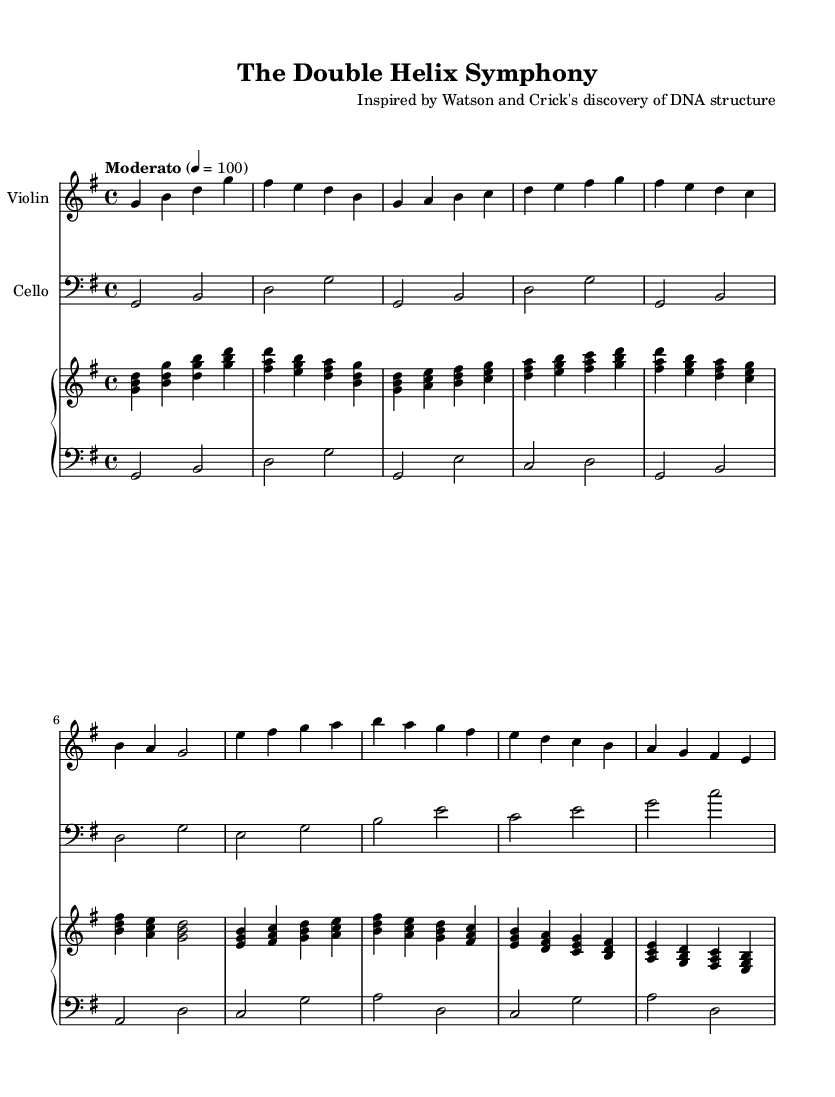what is the key signature of this music? The key signature is G major, which has one sharp (F#). This can be determined by looking at the key signature indicated at the beginning of the score.
Answer: G major what is the time signature of this music? The time signature is 4/4, as indicated at the beginning of the score. This means there are four beats in a measure and the quarter note gets one beat.
Answer: 4/4 what is the tempo marking for this piece? The tempo marking is "Moderato," which indicates a moderate speed. This is specified just above the staff.
Answer: Moderato how many themes are present in the composition? There are two main themes present in the composition. These can be identified as Theme A and Theme B, each characterized by distinct melodic sequences.
Answer: 2 what is the rhythmic pattern in the Introduction of the Violin part? The introductory rhythmic pattern in the Violin part primarily utilizes quarter notes and half notes. By analyzing the rhythmic values in the Introduction section, the notes can be counted to confirm this pattern.
Answer: Quarter and half notes which instrument has the lowest pitch range in this score? The instrument with the lowest pitch range is the Cello, which is in the bass clef and typically plays notes lower than the Violin and Piano parts. The clefs and the range of notes for each instrument indicate their respective pitch ranges.
Answer: Cello what is the relationship between Theme A and Theme B? Theme A introduces a melody that is then contrasted by the different melody of Theme B. The themes can be compared based on their melodic structure and how they progress throughout the composition. This juxtaposition often highlights the emotional and dynamic contrasts in the music.
Answer: Contrast 